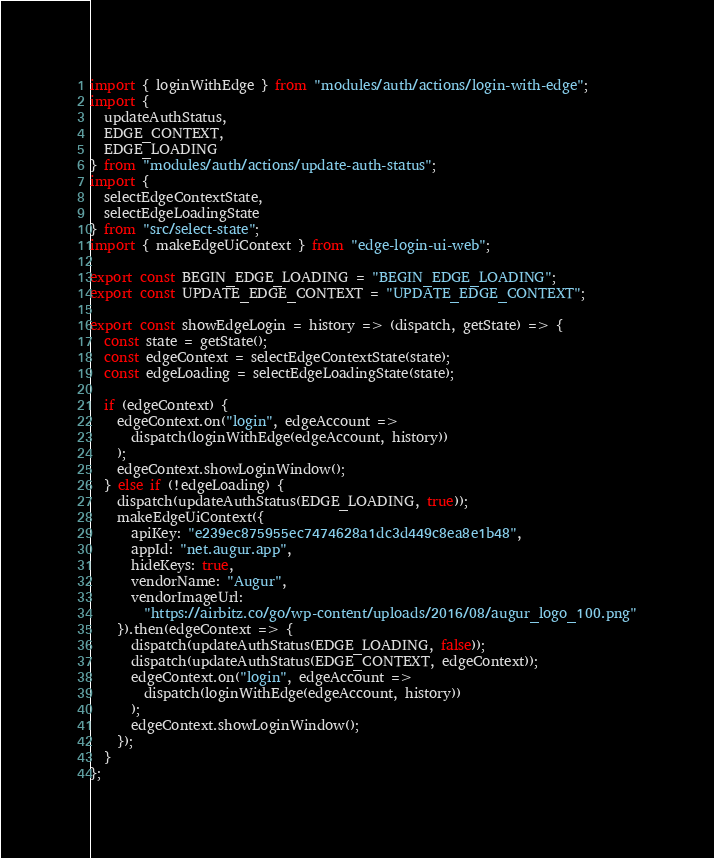<code> <loc_0><loc_0><loc_500><loc_500><_JavaScript_>import { loginWithEdge } from "modules/auth/actions/login-with-edge";
import {
  updateAuthStatus,
  EDGE_CONTEXT,
  EDGE_LOADING
} from "modules/auth/actions/update-auth-status";
import {
  selectEdgeContextState,
  selectEdgeLoadingState
} from "src/select-state";
import { makeEdgeUiContext } from "edge-login-ui-web";

export const BEGIN_EDGE_LOADING = "BEGIN_EDGE_LOADING";
export const UPDATE_EDGE_CONTEXT = "UPDATE_EDGE_CONTEXT";

export const showEdgeLogin = history => (dispatch, getState) => {
  const state = getState();
  const edgeContext = selectEdgeContextState(state);
  const edgeLoading = selectEdgeLoadingState(state);

  if (edgeContext) {
    edgeContext.on("login", edgeAccount =>
      dispatch(loginWithEdge(edgeAccount, history))
    );
    edgeContext.showLoginWindow();
  } else if (!edgeLoading) {
    dispatch(updateAuthStatus(EDGE_LOADING, true));
    makeEdgeUiContext({
      apiKey: "e239ec875955ec7474628a1dc3d449c8ea8e1b48",
      appId: "net.augur.app",
      hideKeys: true,
      vendorName: "Augur",
      vendorImageUrl:
        "https://airbitz.co/go/wp-content/uploads/2016/08/augur_logo_100.png"
    }).then(edgeContext => {
      dispatch(updateAuthStatus(EDGE_LOADING, false));
      dispatch(updateAuthStatus(EDGE_CONTEXT, edgeContext));
      edgeContext.on("login", edgeAccount =>
        dispatch(loginWithEdge(edgeAccount, history))
      );
      edgeContext.showLoginWindow();
    });
  }
};
</code> 